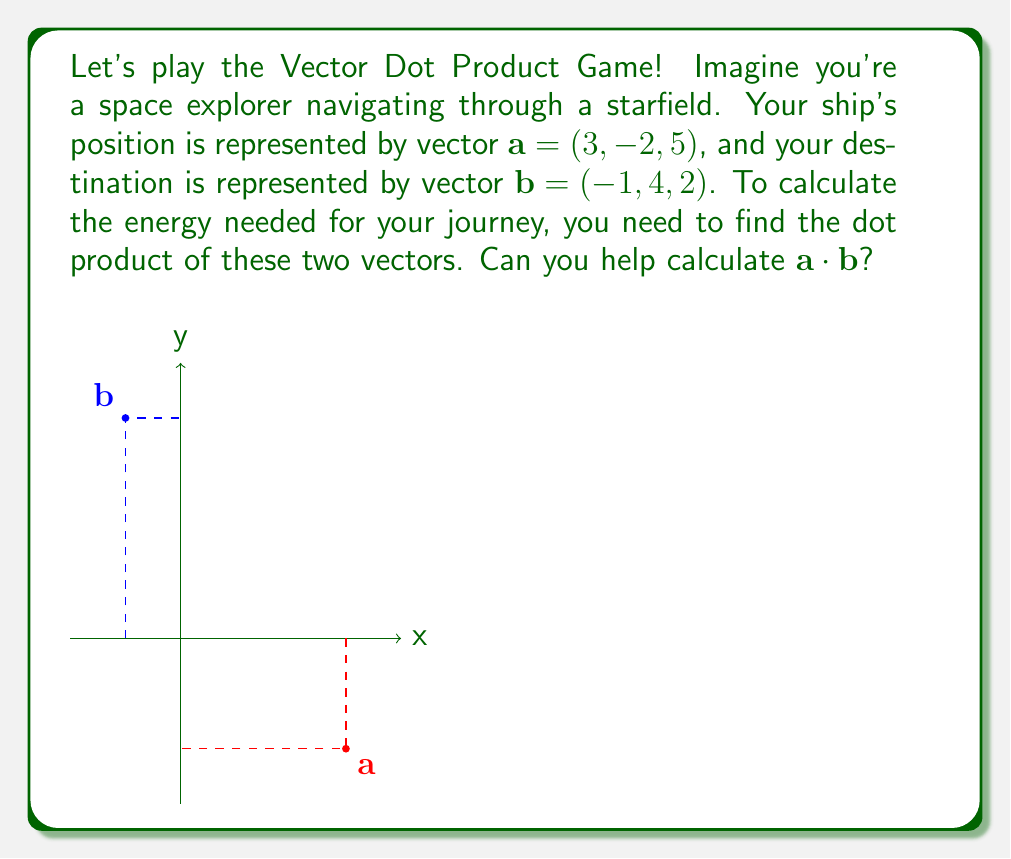Give your solution to this math problem. Let's break this down step-by-step:

1) The dot product of two vectors $\mathbf{a} = (a_1, a_2, a_3)$ and $\mathbf{b} = (b_1, b_2, b_3)$ is defined as:

   $$\mathbf{a} \cdot \mathbf{b} = a_1b_1 + a_2b_2 + a_3b_3$$

2) In our case:
   $\mathbf{a} = (3, -2, 5)$ and $\mathbf{b} = (-1, 4, 2)$

3) Let's substitute these values into the formula:

   $$\mathbf{a} \cdot \mathbf{b} = (3)(-1) + (-2)(4) + (5)(2)$$

4) Now, let's calculate each term:
   - First term: $3 \times (-1) = -3$
   - Second term: $(-2) \times 4 = -8$
   - Third term: $5 \times 2 = 10$

5) Finally, we sum these terms:

   $$\mathbf{a} \cdot \mathbf{b} = -3 + (-8) + 10 = -1$$

Therefore, the dot product of vectors $\mathbf{a}$ and $\mathbf{b}$ is -1.
Answer: $-1$ 